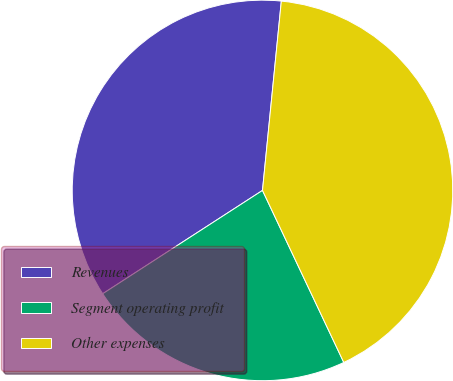<chart> <loc_0><loc_0><loc_500><loc_500><pie_chart><fcel>Revenues<fcel>Segment operating profit<fcel>Other expenses<nl><fcel>35.71%<fcel>22.89%<fcel>41.39%<nl></chart> 